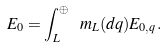<formula> <loc_0><loc_0><loc_500><loc_500>E _ { 0 } = \int _ { L } ^ { \oplus } \ m _ { L } ( d q ) E _ { 0 , q } .</formula> 